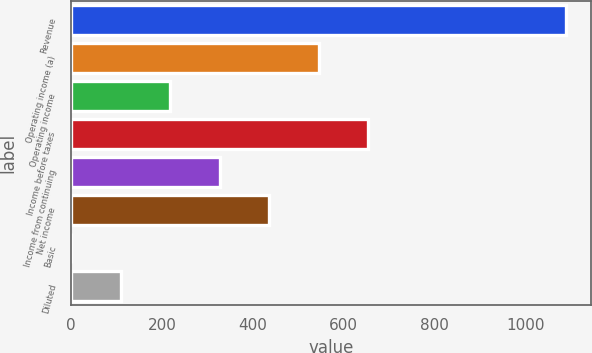<chart> <loc_0><loc_0><loc_500><loc_500><bar_chart><fcel>Revenue<fcel>Operating income (a)<fcel>Operating income<fcel>Income before taxes<fcel>Income from continuing<fcel>Net income<fcel>Basic<fcel>Diluted<nl><fcel>1089.3<fcel>544.94<fcel>218.33<fcel>653.81<fcel>327.2<fcel>436.07<fcel>0.59<fcel>109.46<nl></chart> 